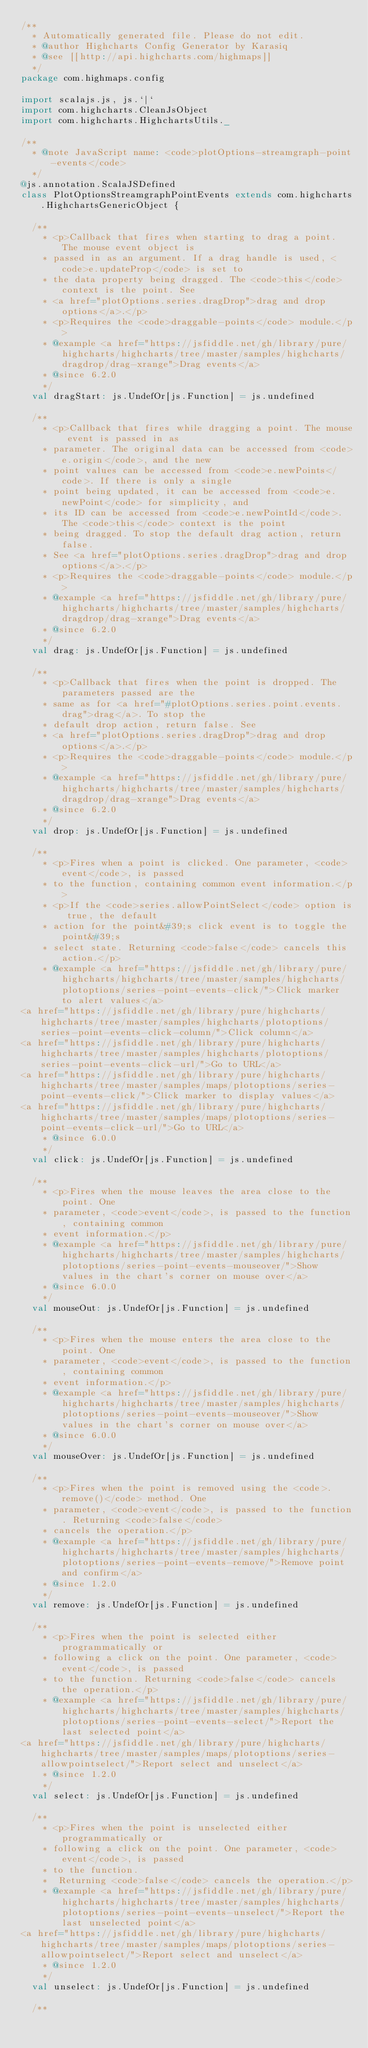Convert code to text. <code><loc_0><loc_0><loc_500><loc_500><_Scala_>/**
  * Automatically generated file. Please do not edit.
  * @author Highcharts Config Generator by Karasiq
  * @see [[http://api.highcharts.com/highmaps]]
  */
package com.highmaps.config

import scalajs.js, js.`|`
import com.highcharts.CleanJsObject
import com.highcharts.HighchartsUtils._

/**
  * @note JavaScript name: <code>plotOptions-streamgraph-point-events</code>
  */
@js.annotation.ScalaJSDefined
class PlotOptionsStreamgraphPointEvents extends com.highcharts.HighchartsGenericObject {

  /**
    * <p>Callback that fires when starting to drag a point. The mouse event object is
    * passed in as an argument. If a drag handle is used, <code>e.updateProp</code> is set to
    * the data property being dragged. The <code>this</code> context is the point. See
    * <a href="plotOptions.series.dragDrop">drag and drop options</a>.</p>
    * <p>Requires the <code>draggable-points</code> module.</p>
    * @example <a href="https://jsfiddle.net/gh/library/pure/highcharts/highcharts/tree/master/samples/highcharts/dragdrop/drag-xrange">Drag events</a>
    * @since 6.2.0
    */
  val dragStart: js.UndefOr[js.Function] = js.undefined

  /**
    * <p>Callback that fires while dragging a point. The mouse event is passed in as
    * parameter. The original data can be accessed from <code>e.origin</code>, and the new
    * point values can be accessed from <code>e.newPoints</code>. If there is only a single
    * point being updated, it can be accessed from <code>e.newPoint</code> for simplicity, and
    * its ID can be accessed from <code>e.newPointId</code>. The <code>this</code> context is the point
    * being dragged. To stop the default drag action, return false.
    * See <a href="plotOptions.series.dragDrop">drag and drop options</a>.</p>
    * <p>Requires the <code>draggable-points</code> module.</p>
    * @example <a href="https://jsfiddle.net/gh/library/pure/highcharts/highcharts/tree/master/samples/highcharts/dragdrop/drag-xrange">Drag events</a>
    * @since 6.2.0
    */
  val drag: js.UndefOr[js.Function] = js.undefined

  /**
    * <p>Callback that fires when the point is dropped. The parameters passed are the
    * same as for <a href="#plotOptions.series.point.events.drag">drag</a>. To stop the
    * default drop action, return false. See
    * <a href="plotOptions.series.dragDrop">drag and drop options</a>.</p>
    * <p>Requires the <code>draggable-points</code> module.</p>
    * @example <a href="https://jsfiddle.net/gh/library/pure/highcharts/highcharts/tree/master/samples/highcharts/dragdrop/drag-xrange">Drag events</a>
    * @since 6.2.0
    */
  val drop: js.UndefOr[js.Function] = js.undefined

  /**
    * <p>Fires when a point is clicked. One parameter, <code>event</code>, is passed
    * to the function, containing common event information.</p>
    * <p>If the <code>series.allowPointSelect</code> option is true, the default
    * action for the point&#39;s click event is to toggle the point&#39;s
    * select state. Returning <code>false</code> cancels this action.</p>
    * @example <a href="https://jsfiddle.net/gh/library/pure/highcharts/highcharts/tree/master/samples/highcharts/plotoptions/series-point-events-click/">Click marker to alert values</a>
<a href="https://jsfiddle.net/gh/library/pure/highcharts/highcharts/tree/master/samples/highcharts/plotoptions/series-point-events-click-column/">Click column</a>
<a href="https://jsfiddle.net/gh/library/pure/highcharts/highcharts/tree/master/samples/highcharts/plotoptions/series-point-events-click-url/">Go to URL</a>
<a href="https://jsfiddle.net/gh/library/pure/highcharts/highcharts/tree/master/samples/maps/plotoptions/series-point-events-click/">Click marker to display values</a>
<a href="https://jsfiddle.net/gh/library/pure/highcharts/highcharts/tree/master/samples/maps/plotoptions/series-point-events-click-url/">Go to URL</a>
    * @since 6.0.0
    */
  val click: js.UndefOr[js.Function] = js.undefined

  /**
    * <p>Fires when the mouse leaves the area close to the point. One
    * parameter, <code>event</code>, is passed to the function, containing common
    * event information.</p>
    * @example <a href="https://jsfiddle.net/gh/library/pure/highcharts/highcharts/tree/master/samples/highcharts/plotoptions/series-point-events-mouseover/">Show values in the chart's corner on mouse over</a>
    * @since 6.0.0
    */
  val mouseOut: js.UndefOr[js.Function] = js.undefined

  /**
    * <p>Fires when the mouse enters the area close to the point. One
    * parameter, <code>event</code>, is passed to the function, containing common
    * event information.</p>
    * @example <a href="https://jsfiddle.net/gh/library/pure/highcharts/highcharts/tree/master/samples/highcharts/plotoptions/series-point-events-mouseover/">Show values in the chart's corner on mouse over</a>
    * @since 6.0.0
    */
  val mouseOver: js.UndefOr[js.Function] = js.undefined

  /**
    * <p>Fires when the point is removed using the <code>.remove()</code> method. One
    * parameter, <code>event</code>, is passed to the function. Returning <code>false</code>
    * cancels the operation.</p>
    * @example <a href="https://jsfiddle.net/gh/library/pure/highcharts/highcharts/tree/master/samples/highcharts/plotoptions/series-point-events-remove/">Remove point and confirm</a>
    * @since 1.2.0
    */
  val remove: js.UndefOr[js.Function] = js.undefined

  /**
    * <p>Fires when the point is selected either programmatically or
    * following a click on the point. One parameter, <code>event</code>, is passed
    * to the function. Returning <code>false</code> cancels the operation.</p>
    * @example <a href="https://jsfiddle.net/gh/library/pure/highcharts/highcharts/tree/master/samples/highcharts/plotoptions/series-point-events-select/">Report the last selected point</a>
<a href="https://jsfiddle.net/gh/library/pure/highcharts/highcharts/tree/master/samples/maps/plotoptions/series-allowpointselect/">Report select and unselect</a>
    * @since 1.2.0
    */
  val select: js.UndefOr[js.Function] = js.undefined

  /**
    * <p>Fires when the point is unselected either programmatically or
    * following a click on the point. One parameter, <code>event</code>, is passed
    * to the function.
    *  Returning <code>false</code> cancels the operation.</p>
    * @example <a href="https://jsfiddle.net/gh/library/pure/highcharts/highcharts/tree/master/samples/highcharts/plotoptions/series-point-events-unselect/">Report the last unselected point</a>
<a href="https://jsfiddle.net/gh/library/pure/highcharts/highcharts/tree/master/samples/maps/plotoptions/series-allowpointselect/">Report select and unselect</a>
    * @since 1.2.0
    */
  val unselect: js.UndefOr[js.Function] = js.undefined

  /**</code> 